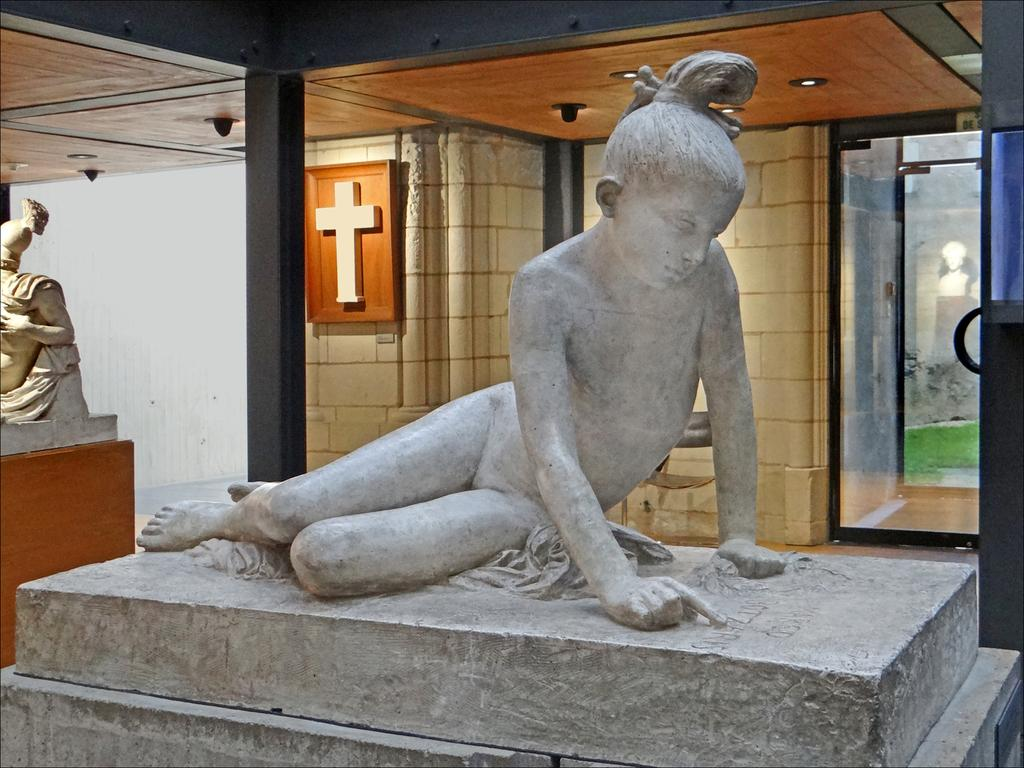What type of objects can be seen in the image? There are statues and pillars in the image. What other elements are present in the image? There are lights, glass, and a frame on the wall in the image. What is depicted within the frame on the wall? The frame contains a cross. What can be seen in the background of the image? There is grass and a statue visible in the background of the image. How does the statue in the background of the image draw attention to the blood on the grass? There is no blood present in the image, and the statue does not draw attention to any specific element. 